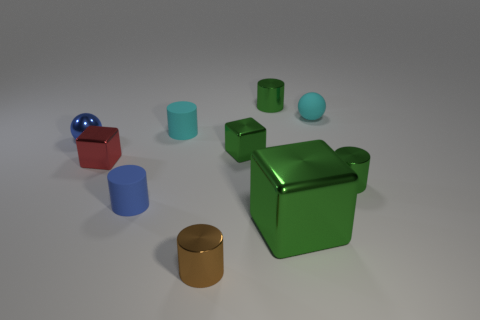Subtract all cyan cylinders. How many cylinders are left? 4 Subtract all tiny cyan cylinders. How many cylinders are left? 4 Subtract all cyan cylinders. Subtract all brown spheres. How many cylinders are left? 4 Subtract all spheres. How many objects are left? 8 Add 5 green blocks. How many green blocks exist? 7 Subtract 0 yellow blocks. How many objects are left? 10 Subtract all cyan rubber cylinders. Subtract all purple matte things. How many objects are left? 9 Add 1 tiny brown objects. How many tiny brown objects are left? 2 